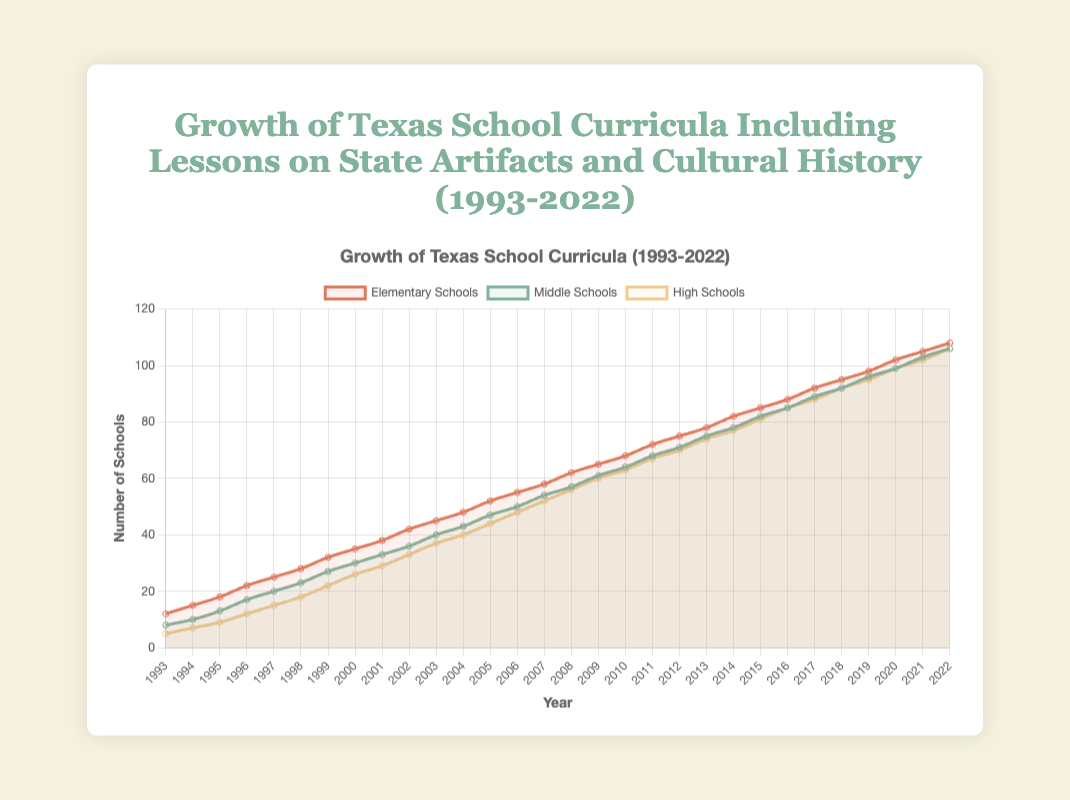What year did Elementary Schools first surpass 50 schools implementing the curriculum? Looking at the line for Elementary Schools, we can see it surpasses 50 in the year 2005.
Answer: 2005 Which type of school had the lowest number of implementations in 1993? By comparing the numbers for each school type in 1993, Elementary Schools had 12, Middle Schools had 8, and High Schools had 5. High Schools had the lowest number of implementations.
Answer: High Schools By how much did Middle Schools increase their curriculum implementations between 2000 and 2010? In 2000, Middle Schools had 30 implementations, and by 2010, they had 64 implementations. The difference is 64 - 30.
Answer: 34 Are there any years when Middle Schools and High Schools have the same number of curriculum implementations? By closely examining the lines for Middle Schools and High Schools, we can notice that they both have 85 implementations in 2016 and 106 implementations in 2022.
Answer: 2016, 2022 What is the overall growth in the number of Elementary Schools from 1993 to 2022? In 1993, there were 12 Elementary Schools, and in 2022, there are 108. The overall growth is 108 - 12.
Answer: 96 When was the pace of growth for High Schools the fastest based on visual inspection? By observing the steepness of the High School line, the period from 1999 to 2005 shows the steepest incline, indicating the fastest growth.
Answer: 1999-2005 Between 1997 and 2002, did Elementary Schools or Middle Schools see a greater increase in the number of schools implementing the curriculum? Elementary Schools increased from 25 to 42 (a growth of 17), while Middle Schools increased from 20 to 36 (a growth of 16).
Answer: Elementary Schools What was the average number of High Schools implementing the curriculum between 1998 and 2002? Summing the number of High Schools for the years 1998, 1999, 2000, 2001, and 2002 ((18 + 22 + 26 + 29 + 33) = 128) and dividing by 5 gives the average.
Answer: 25.6 In which year did Middle Schools first reach 50 schools implementing the curriculum? The line for Middle Schools crosses the 50 mark in the year 2006.
Answer: 2006 How did the number of Elementary Schools, Middle Schools, and High Schools compare in 2021? In 2021, Elementary Schools had 105, Middle Schools had 103, and High Schools had 102 implementations.
Answer: Elementary Schools > Middle Schools > High Schools 